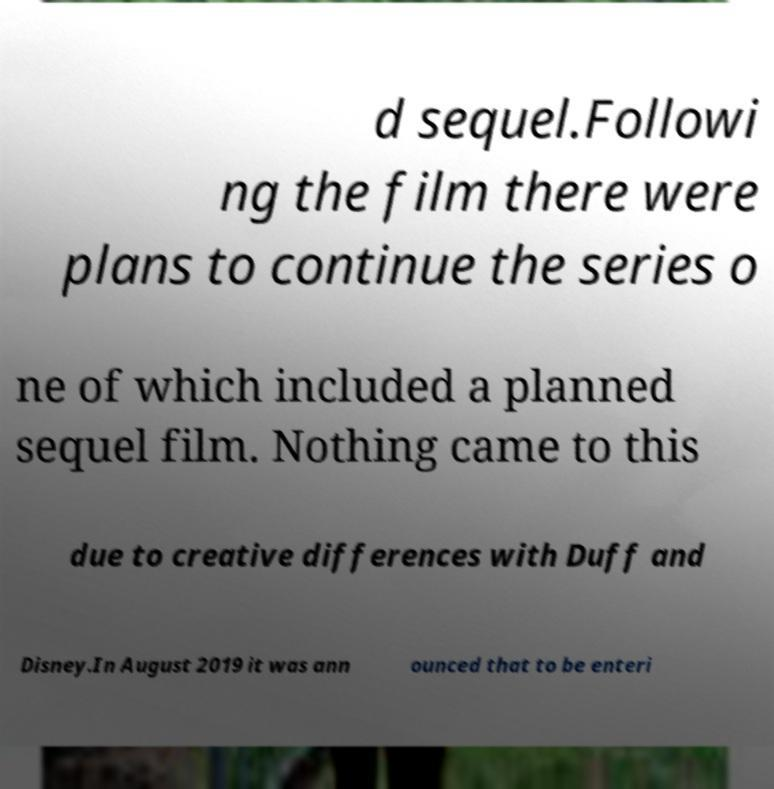There's text embedded in this image that I need extracted. Can you transcribe it verbatim? d sequel.Followi ng the film there were plans to continue the series o ne of which included a planned sequel film. Nothing came to this due to creative differences with Duff and Disney.In August 2019 it was ann ounced that to be enteri 